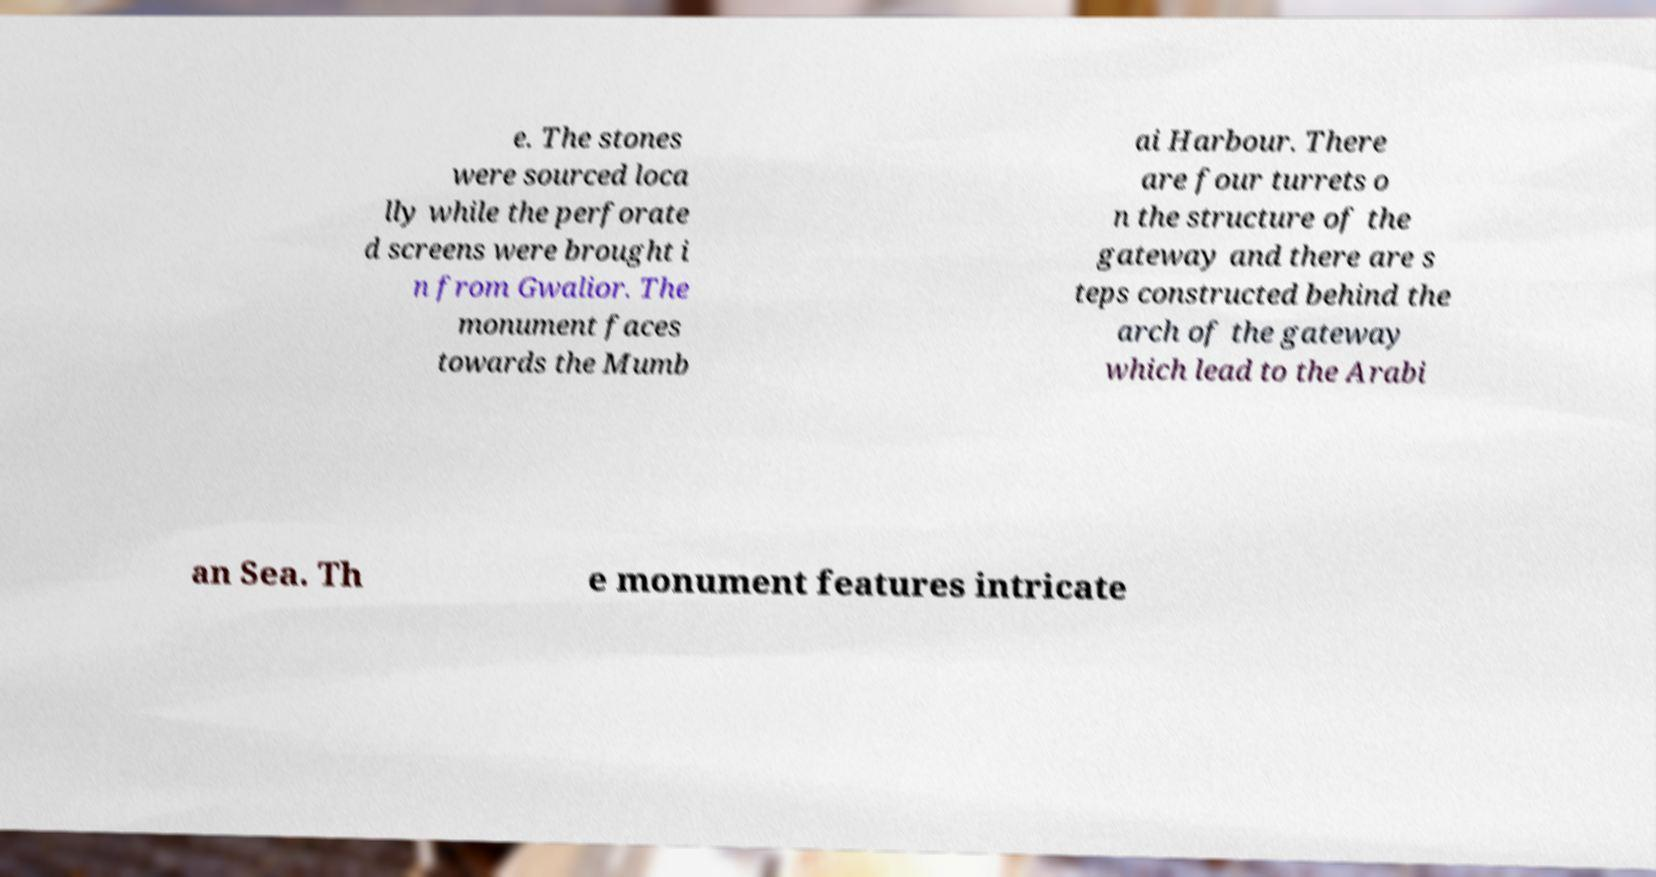Please read and relay the text visible in this image. What does it say? e. The stones were sourced loca lly while the perforate d screens were brought i n from Gwalior. The monument faces towards the Mumb ai Harbour. There are four turrets o n the structure of the gateway and there are s teps constructed behind the arch of the gateway which lead to the Arabi an Sea. Th e monument features intricate 